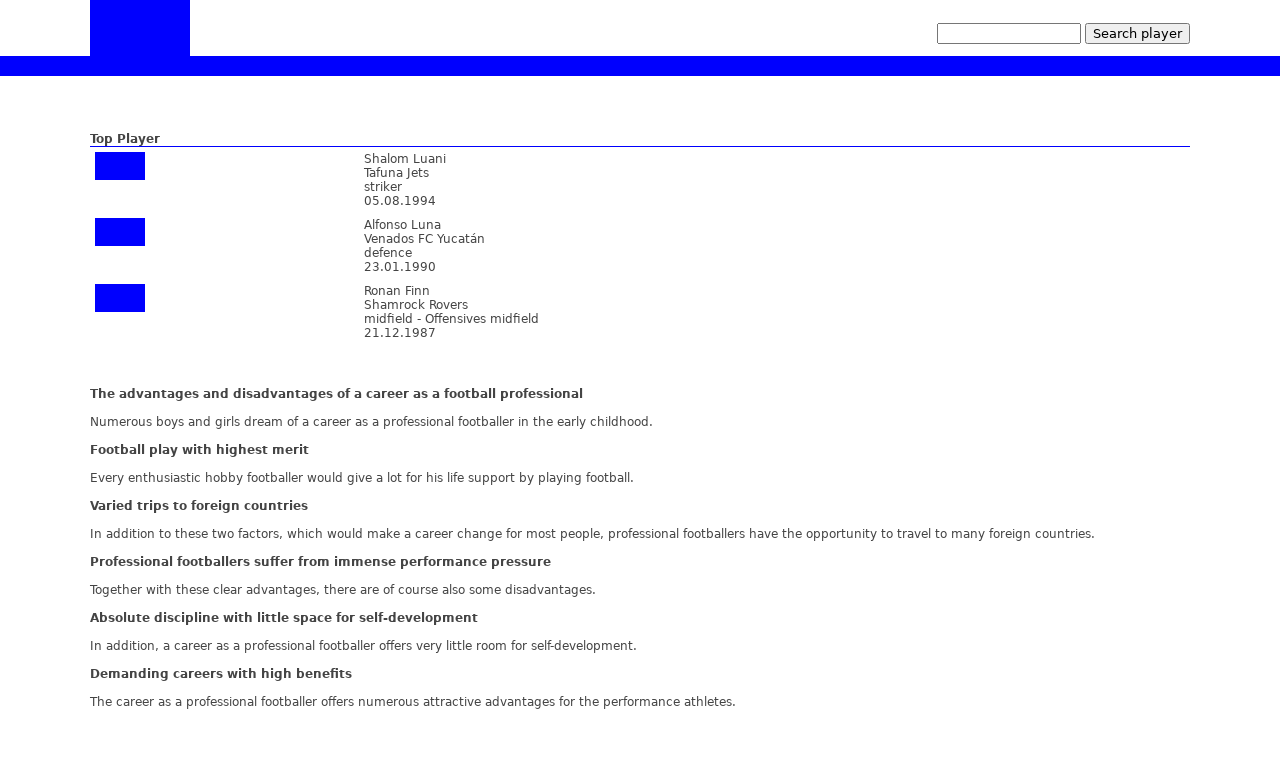What advice would you give someone based on the pros and cons listed here for becoming a professional football player? Considering the pros and cons listed, anyone aspiring to become a professional football player should be prepared for a demanding career that requires immense discipline, resilience in the face of pressure, and a deep commitment to the sport. They should ensure they are passionate about football, are ready for the challenges ahead, and are willing to sacrifice in other life areas. Nonethless, the rewards can be tremendously fulfilling, not only financially but also through the experiences and growth such a career offers. 